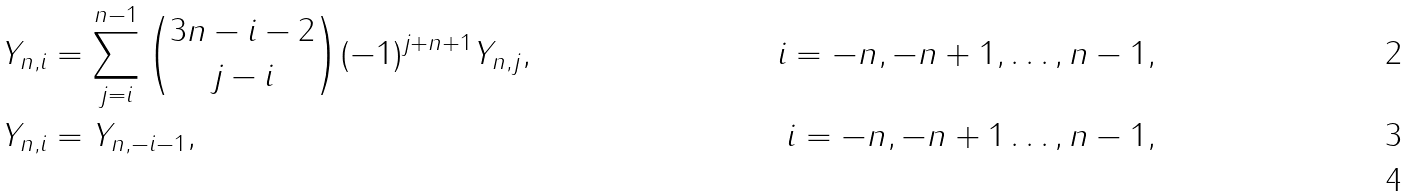Convert formula to latex. <formula><loc_0><loc_0><loc_500><loc_500>Y _ { n , i } & = \sum _ { j = i } ^ { n - 1 } \binom { 3 n - i - 2 } { j - i } ( - 1 ) ^ { j + n + 1 } Y _ { n , j } , & i = - n , - n + 1 , \dots , n - 1 , \\ Y _ { n , i } & = Y _ { n , - i - 1 } , & i = - n , - n + 1 \dots , n - 1 , \\</formula> 